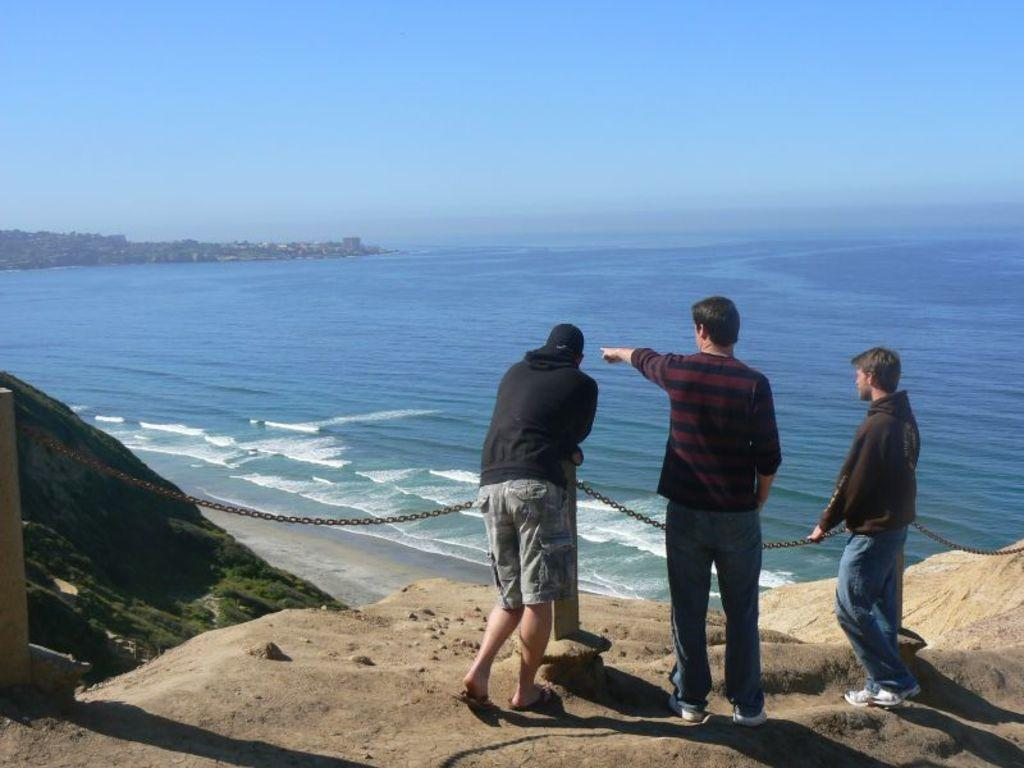How many people are in the image? There are three men standing in the image. What is in front of the men? There is a chain on poles in front of the men. What can be seen in the background of the image? There is water and the sky visible in the background of the image. Can you see any ants crawling on the men in the image? There are no ants visible in the image; it only shows three men standing with a chain on poles in front of them. 